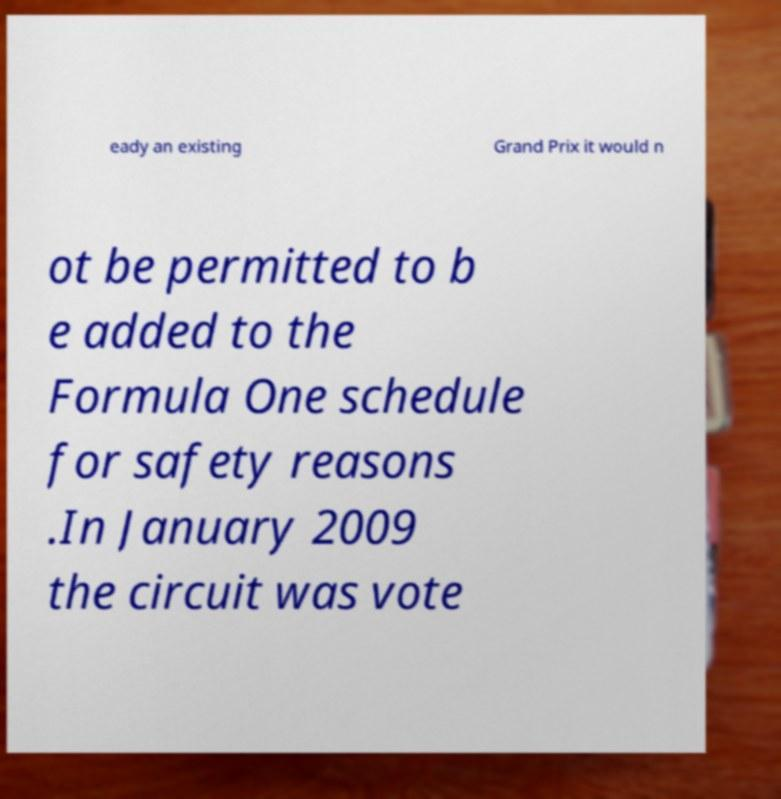Can you read and provide the text displayed in the image?This photo seems to have some interesting text. Can you extract and type it out for me? eady an existing Grand Prix it would n ot be permitted to b e added to the Formula One schedule for safety reasons .In January 2009 the circuit was vote 